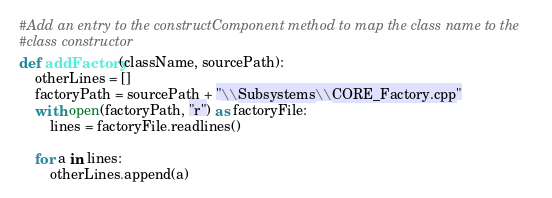Convert code to text. <code><loc_0><loc_0><loc_500><loc_500><_Python_>#Add an entry to the constructComponent method to map the class name to the
#class constructor
def addFactory(className, sourcePath):
    otherLines = []
    factoryPath = sourcePath + "\\Subsystems\\CORE_Factory.cpp"
    with open(factoryPath, "r") as factoryFile:
        lines = factoryFile.readlines()

    for a in lines:    
        otherLines.append(a)</code> 